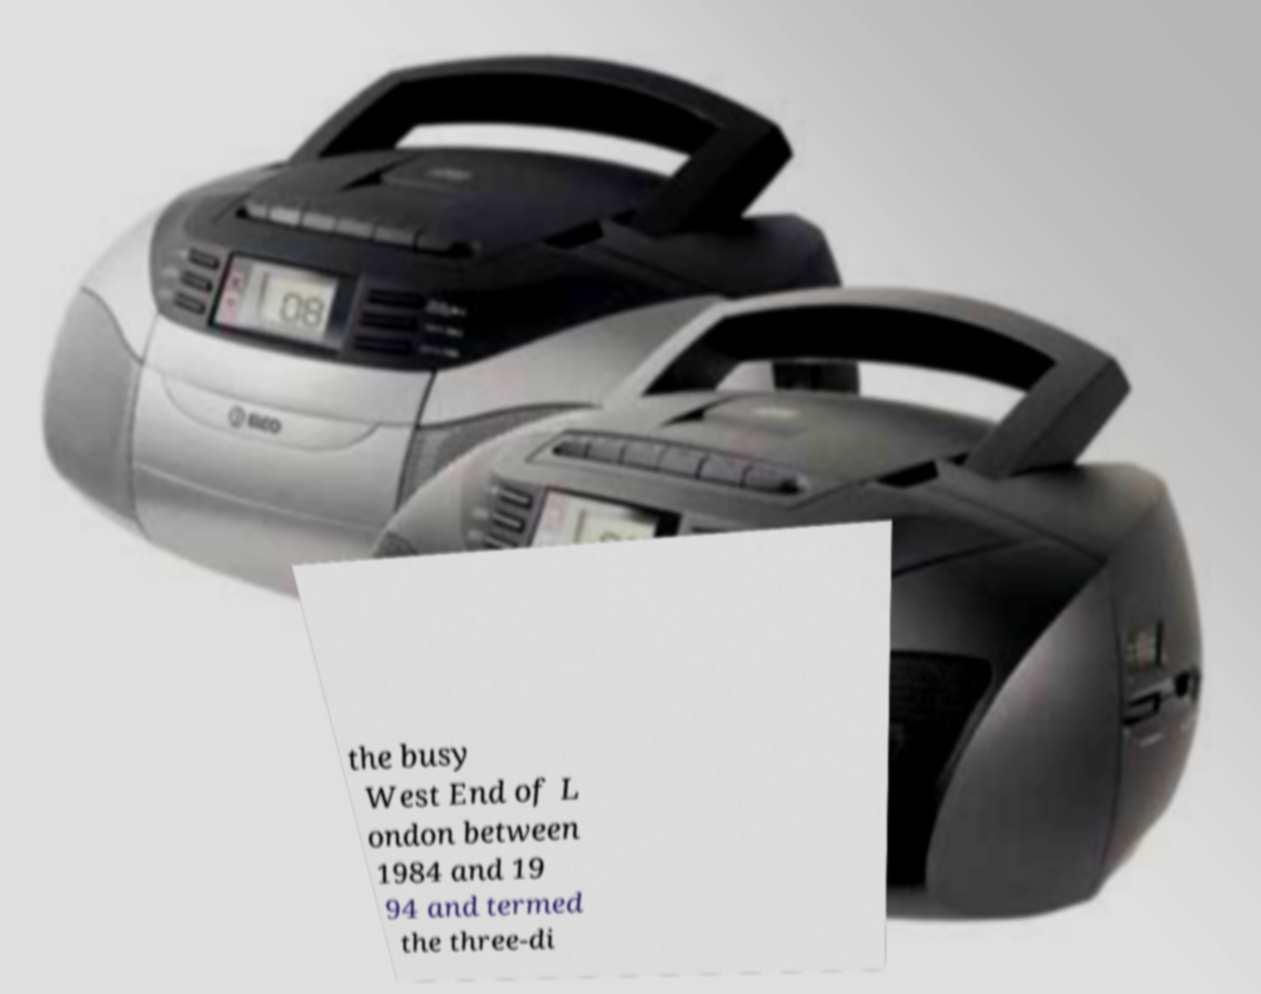For documentation purposes, I need the text within this image transcribed. Could you provide that? the busy West End of L ondon between 1984 and 19 94 and termed the three-di 